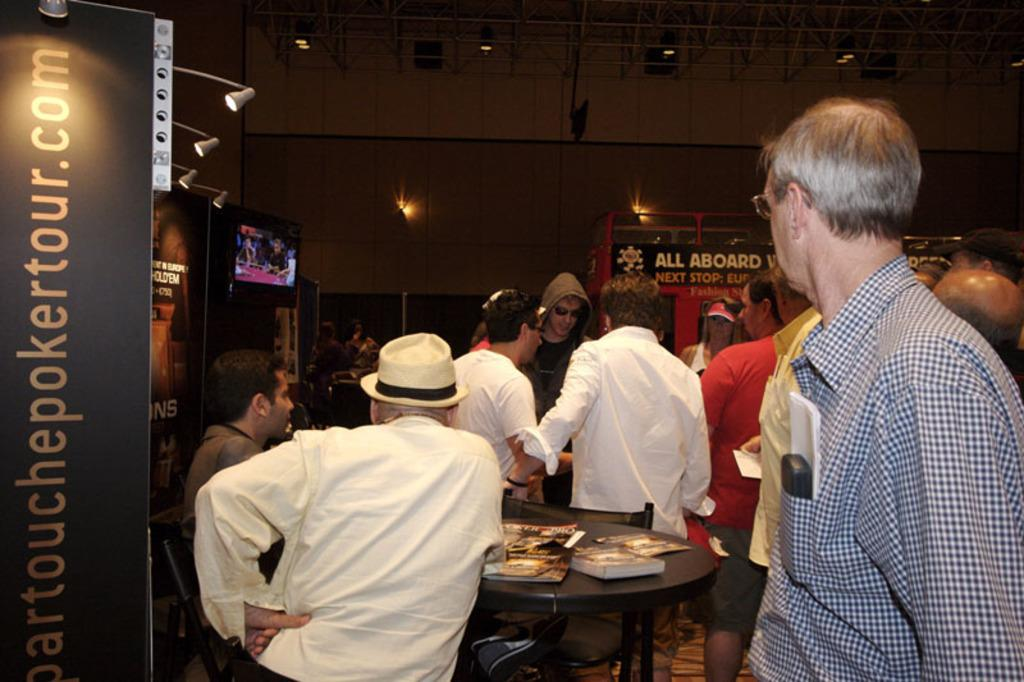What can be seen in the image involving a group of people? There is a group of people in the image. What objects are present on the table in the image? There are books on a table in the image. What is located on the left side of the image? There are hoardings and a television on the left side of the image. What can be seen at the top of the image? There are lights visible at the top of the image. What type of skirt is the baby wearing in the image? There is no baby or skirt present in the image. What does the sister of the person in the image say about the hoardings? There is no mention of a sister or any dialogue in the image, so it is not possible to answer this question. 